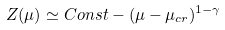Convert formula to latex. <formula><loc_0><loc_0><loc_500><loc_500>Z ( \mu ) \simeq C o n s t - ( \mu - \mu _ { c r } ) ^ { 1 - \gamma }</formula> 